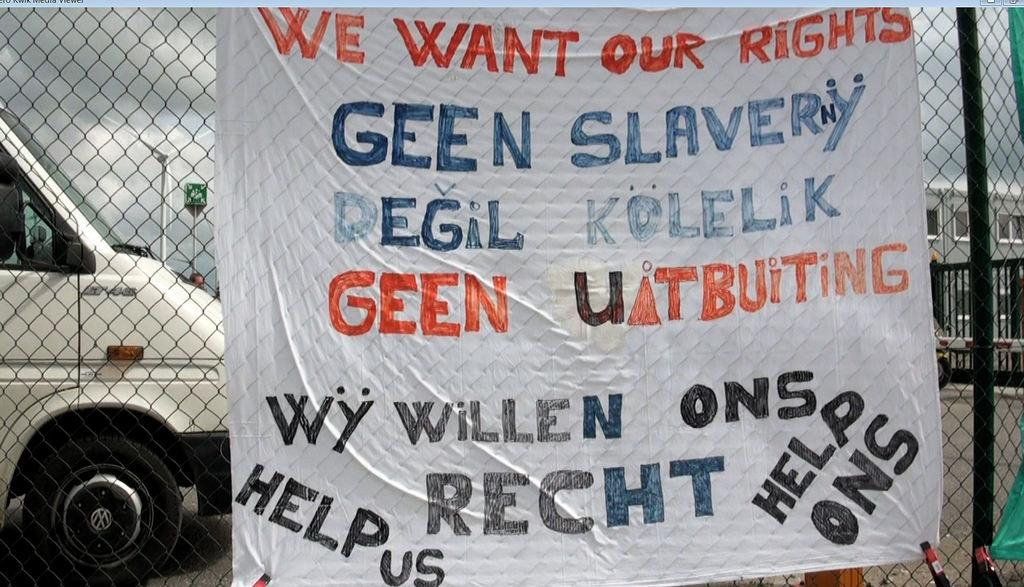What is attached to the mesh in the image? There is a banner on the mesh. What can be seen through the mesh besides the banner? Vehicles, a person's head, a windmill, buildings, and the sky can be seen through the mesh. Can you describe the objects visible through the mesh? Vehicles, a person's head, a windmill, and buildings are all stationary objects, while the sky suggests the presence of weather or time of day. What type of grass is growing on the scale in the image? There is no grass or scale present in the image. How much smoke is visible in the image? There is no smoke visible in the image. 